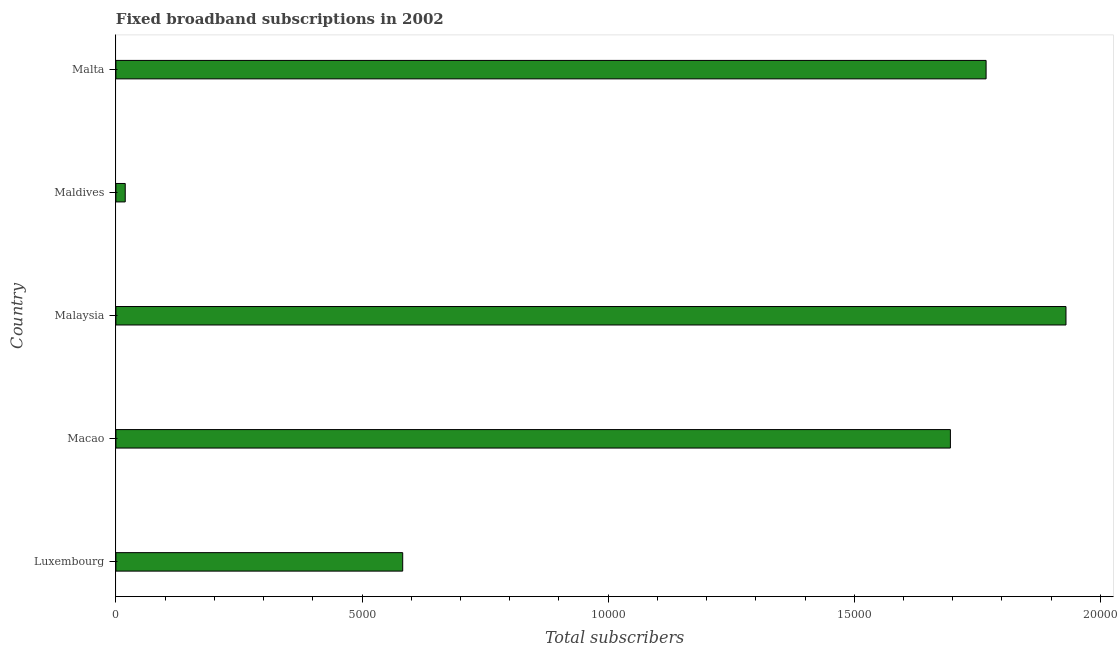What is the title of the graph?
Provide a succinct answer. Fixed broadband subscriptions in 2002. What is the label or title of the X-axis?
Ensure brevity in your answer.  Total subscribers. What is the label or title of the Y-axis?
Make the answer very short. Country. What is the total number of fixed broadband subscriptions in Maldives?
Give a very brief answer. 190. Across all countries, what is the maximum total number of fixed broadband subscriptions?
Your response must be concise. 1.93e+04. Across all countries, what is the minimum total number of fixed broadband subscriptions?
Offer a very short reply. 190. In which country was the total number of fixed broadband subscriptions maximum?
Offer a terse response. Malaysia. In which country was the total number of fixed broadband subscriptions minimum?
Your answer should be very brief. Maldives. What is the sum of the total number of fixed broadband subscriptions?
Ensure brevity in your answer.  6.00e+04. What is the difference between the total number of fixed broadband subscriptions in Malaysia and Malta?
Your response must be concise. 1623. What is the average total number of fixed broadband subscriptions per country?
Offer a very short reply. 1.20e+04. What is the median total number of fixed broadband subscriptions?
Provide a succinct answer. 1.70e+04. In how many countries, is the total number of fixed broadband subscriptions greater than 6000 ?
Provide a succinct answer. 3. What is the ratio of the total number of fixed broadband subscriptions in Maldives to that in Malta?
Make the answer very short. 0.01. What is the difference between the highest and the second highest total number of fixed broadband subscriptions?
Your answer should be very brief. 1623. Is the sum of the total number of fixed broadband subscriptions in Luxembourg and Malta greater than the maximum total number of fixed broadband subscriptions across all countries?
Give a very brief answer. Yes. What is the difference between the highest and the lowest total number of fixed broadband subscriptions?
Provide a succinct answer. 1.91e+04. How many bars are there?
Your response must be concise. 5. What is the difference between two consecutive major ticks on the X-axis?
Give a very brief answer. 5000. What is the Total subscribers in Luxembourg?
Ensure brevity in your answer.  5827. What is the Total subscribers of Macao?
Keep it short and to the point. 1.70e+04. What is the Total subscribers of Malaysia?
Provide a short and direct response. 1.93e+04. What is the Total subscribers of Maldives?
Your answer should be compact. 190. What is the Total subscribers in Malta?
Keep it short and to the point. 1.77e+04. What is the difference between the Total subscribers in Luxembourg and Macao?
Keep it short and to the point. -1.11e+04. What is the difference between the Total subscribers in Luxembourg and Malaysia?
Keep it short and to the point. -1.35e+04. What is the difference between the Total subscribers in Luxembourg and Maldives?
Your answer should be compact. 5637. What is the difference between the Total subscribers in Luxembourg and Malta?
Offer a terse response. -1.19e+04. What is the difference between the Total subscribers in Macao and Malaysia?
Give a very brief answer. -2348. What is the difference between the Total subscribers in Macao and Maldives?
Your answer should be very brief. 1.68e+04. What is the difference between the Total subscribers in Macao and Malta?
Offer a terse response. -725. What is the difference between the Total subscribers in Malaysia and Maldives?
Keep it short and to the point. 1.91e+04. What is the difference between the Total subscribers in Malaysia and Malta?
Your answer should be compact. 1623. What is the difference between the Total subscribers in Maldives and Malta?
Your answer should be very brief. -1.75e+04. What is the ratio of the Total subscribers in Luxembourg to that in Macao?
Keep it short and to the point. 0.34. What is the ratio of the Total subscribers in Luxembourg to that in Malaysia?
Ensure brevity in your answer.  0.3. What is the ratio of the Total subscribers in Luxembourg to that in Maldives?
Make the answer very short. 30.67. What is the ratio of the Total subscribers in Luxembourg to that in Malta?
Offer a terse response. 0.33. What is the ratio of the Total subscribers in Macao to that in Malaysia?
Offer a terse response. 0.88. What is the ratio of the Total subscribers in Macao to that in Maldives?
Ensure brevity in your answer.  89.23. What is the ratio of the Total subscribers in Malaysia to that in Maldives?
Your answer should be compact. 101.59. What is the ratio of the Total subscribers in Malaysia to that in Malta?
Offer a very short reply. 1.09. What is the ratio of the Total subscribers in Maldives to that in Malta?
Provide a short and direct response. 0.01. 